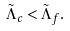<formula> <loc_0><loc_0><loc_500><loc_500>\tilde { \Lambda } _ { c } < \tilde { \Lambda } _ { f } .</formula> 